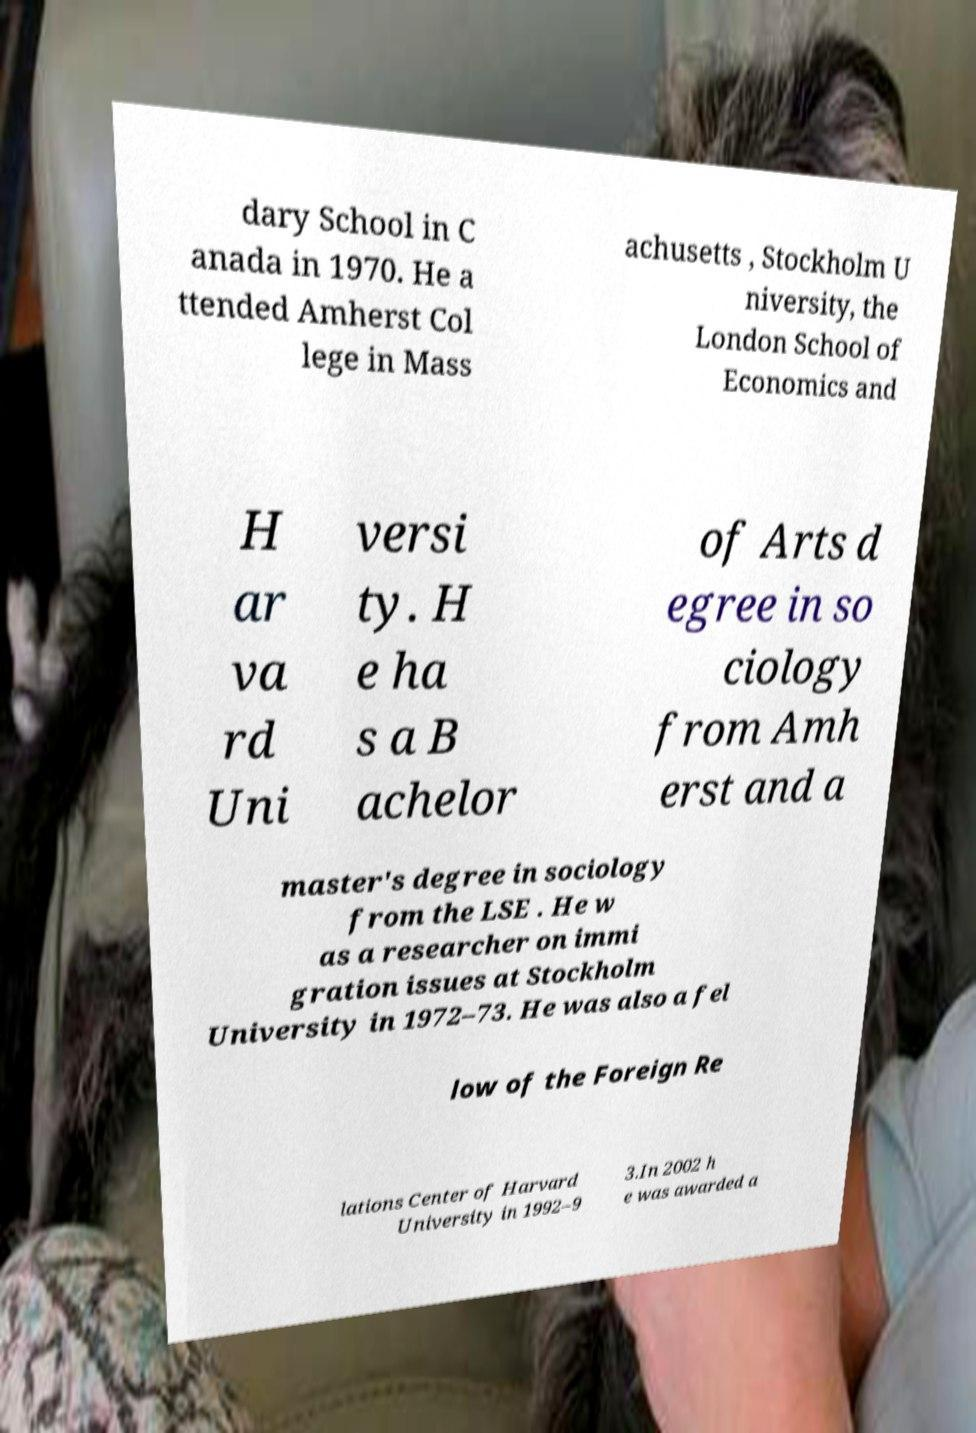Could you extract and type out the text from this image? dary School in C anada in 1970. He a ttended Amherst Col lege in Mass achusetts , Stockholm U niversity, the London School of Economics and H ar va rd Uni versi ty. H e ha s a B achelor of Arts d egree in so ciology from Amh erst and a master's degree in sociology from the LSE . He w as a researcher on immi gration issues at Stockholm University in 1972–73. He was also a fel low of the Foreign Re lations Center of Harvard University in 1992–9 3.In 2002 h e was awarded a 